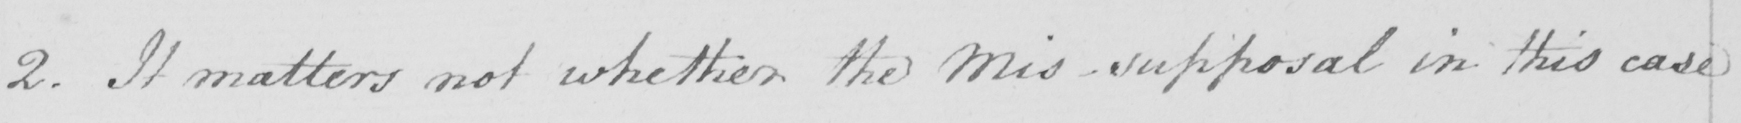Can you tell me what this handwritten text says? 2. It matters not whether the Mis-supposal in this case 